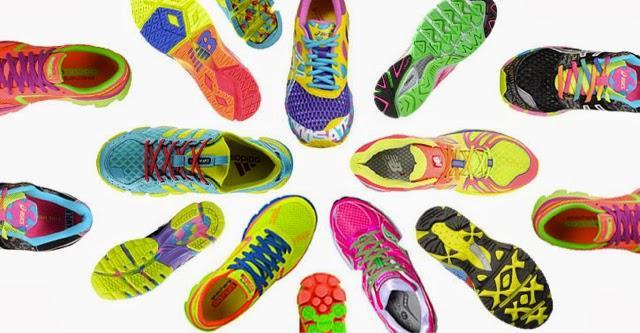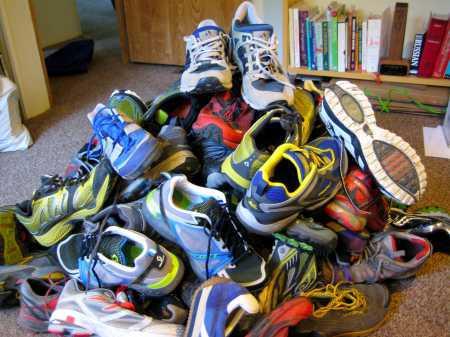The first image is the image on the left, the second image is the image on the right. Analyze the images presented: Is the assertion "In one image only the tops and sides of the shoes are visible." valid? Answer yes or no. No. The first image is the image on the left, the second image is the image on the right. Analyze the images presented: Is the assertion "At least one of the images prominently displays one or more Nike brand shoe with the brand's signature """"swoosh"""" logo on the side." valid? Answer yes or no. No. The first image is the image on the left, the second image is the image on the right. Analyze the images presented: Is the assertion "There is a triangular pile of shoes in the image on the right." valid? Answer yes or no. Yes. The first image is the image on the left, the second image is the image on the right. Assess this claim about the two images: "The shoes in one of the pictures are not piled up on each other.". Correct or not? Answer yes or no. Yes. The first image is the image on the left, the second image is the image on the right. Analyze the images presented: Is the assertion "An image shows no more than a dozen sneakers arranged in a pile with at least one sole visible." valid? Answer yes or no. No. 